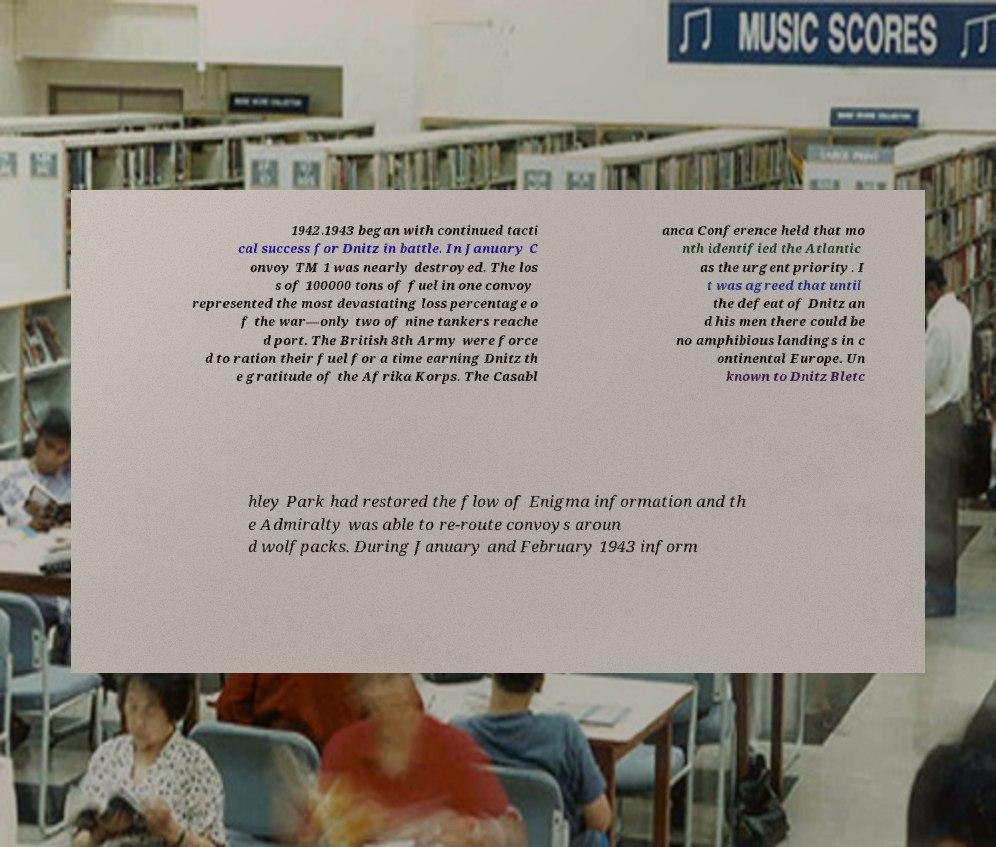There's text embedded in this image that I need extracted. Can you transcribe it verbatim? 1942.1943 began with continued tacti cal success for Dnitz in battle. In January C onvoy TM 1 was nearly destroyed. The los s of 100000 tons of fuel in one convoy represented the most devastating loss percentage o f the war—only two of nine tankers reache d port. The British 8th Army were force d to ration their fuel for a time earning Dnitz th e gratitude of the Afrika Korps. The Casabl anca Conference held that mo nth identified the Atlantic as the urgent priority. I t was agreed that until the defeat of Dnitz an d his men there could be no amphibious landings in c ontinental Europe. Un known to Dnitz Bletc hley Park had restored the flow of Enigma information and th e Admiralty was able to re-route convoys aroun d wolfpacks. During January and February 1943 inform 